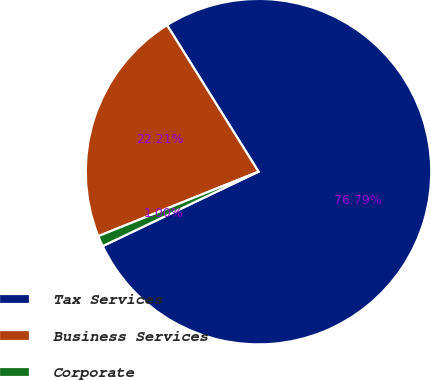Convert chart. <chart><loc_0><loc_0><loc_500><loc_500><pie_chart><fcel>Tax Services<fcel>Business Services<fcel>Corporate<nl><fcel>76.79%<fcel>22.21%<fcel>1.0%<nl></chart> 